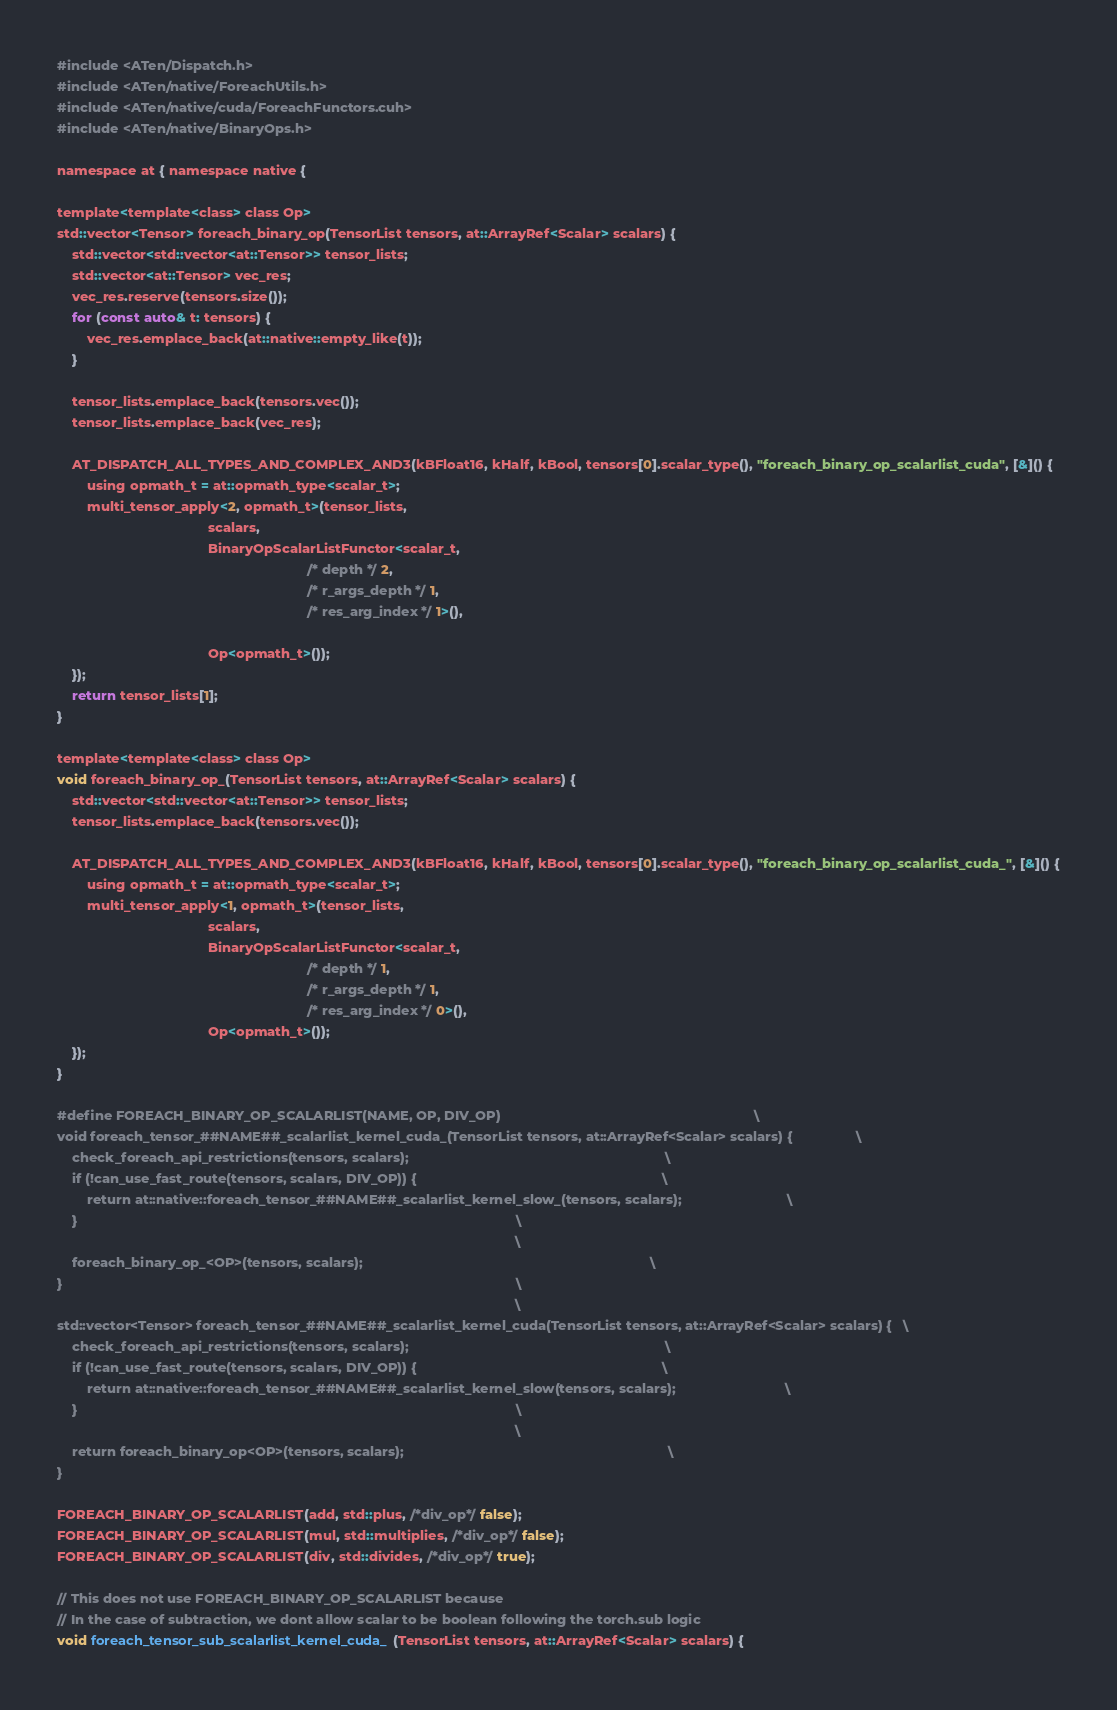Convert code to text. <code><loc_0><loc_0><loc_500><loc_500><_Cuda_>#include <ATen/Dispatch.h>
#include <ATen/native/ForeachUtils.h>
#include <ATen/native/cuda/ForeachFunctors.cuh>
#include <ATen/native/BinaryOps.h>

namespace at { namespace native {

template<template<class> class Op>
std::vector<Tensor> foreach_binary_op(TensorList tensors, at::ArrayRef<Scalar> scalars) {
    std::vector<std::vector<at::Tensor>> tensor_lists;
    std::vector<at::Tensor> vec_res;
    vec_res.reserve(tensors.size());
    for (const auto& t: tensors) {
        vec_res.emplace_back(at::native::empty_like(t));
    }

    tensor_lists.emplace_back(tensors.vec());
    tensor_lists.emplace_back(vec_res);

    AT_DISPATCH_ALL_TYPES_AND_COMPLEX_AND3(kBFloat16, kHalf, kBool, tensors[0].scalar_type(), "foreach_binary_op_scalarlist_cuda", [&]() {
        using opmath_t = at::opmath_type<scalar_t>;
        multi_tensor_apply<2, opmath_t>(tensor_lists,
                                        scalars,
                                        BinaryOpScalarListFunctor<scalar_t,
                                                                  /* depth */ 2,
                                                                  /* r_args_depth */ 1,
                                                                  /* res_arg_index */ 1>(),

                                        Op<opmath_t>());
    });
    return tensor_lists[1];
}

template<template<class> class Op>
void foreach_binary_op_(TensorList tensors, at::ArrayRef<Scalar> scalars) {
    std::vector<std::vector<at::Tensor>> tensor_lists;
    tensor_lists.emplace_back(tensors.vec());

    AT_DISPATCH_ALL_TYPES_AND_COMPLEX_AND3(kBFloat16, kHalf, kBool, tensors[0].scalar_type(), "foreach_binary_op_scalarlist_cuda_", [&]() {
        using opmath_t = at::opmath_type<scalar_t>;
        multi_tensor_apply<1, opmath_t>(tensor_lists,
                                        scalars,
                                        BinaryOpScalarListFunctor<scalar_t,
                                                                  /* depth */ 1,
                                                                  /* r_args_depth */ 1,
                                                                  /* res_arg_index */ 0>(),
                                        Op<opmath_t>());
    });
}

#define FOREACH_BINARY_OP_SCALARLIST(NAME, OP, DIV_OP)                                                                   \
void foreach_tensor_##NAME##_scalarlist_kernel_cuda_(TensorList tensors, at::ArrayRef<Scalar> scalars) {                 \
    check_foreach_api_restrictions(tensors, scalars);                                                                    \
    if (!can_use_fast_route(tensors, scalars, DIV_OP)) {                                                                 \
        return at::native::foreach_tensor_##NAME##_scalarlist_kernel_slow_(tensors, scalars);                            \
    }                                                                                                                    \
                                                                                                                         \
    foreach_binary_op_<OP>(tensors, scalars);                                                                            \
}                                                                                                                        \
                                                                                                                         \
std::vector<Tensor> foreach_tensor_##NAME##_scalarlist_kernel_cuda(TensorList tensors, at::ArrayRef<Scalar> scalars) {   \
    check_foreach_api_restrictions(tensors, scalars);                                                                    \
    if (!can_use_fast_route(tensors, scalars, DIV_OP)) {                                                                 \
        return at::native::foreach_tensor_##NAME##_scalarlist_kernel_slow(tensors, scalars);                             \
    }                                                                                                                    \
                                                                                                                         \
    return foreach_binary_op<OP>(tensors, scalars);                                                                      \
}

FOREACH_BINARY_OP_SCALARLIST(add, std::plus, /*div_op*/ false);
FOREACH_BINARY_OP_SCALARLIST(mul, std::multiplies, /*div_op*/ false);
FOREACH_BINARY_OP_SCALARLIST(div, std::divides, /*div_op*/ true);

// This does not use FOREACH_BINARY_OP_SCALARLIST because
// In the case of subtraction, we dont allow scalar to be boolean following the torch.sub logic
void foreach_tensor_sub_scalarlist_kernel_cuda_(TensorList tensors, at::ArrayRef<Scalar> scalars) {</code> 